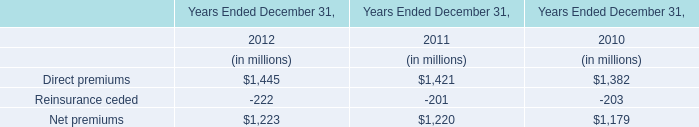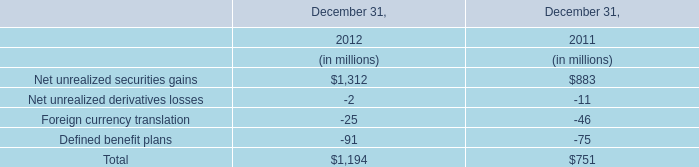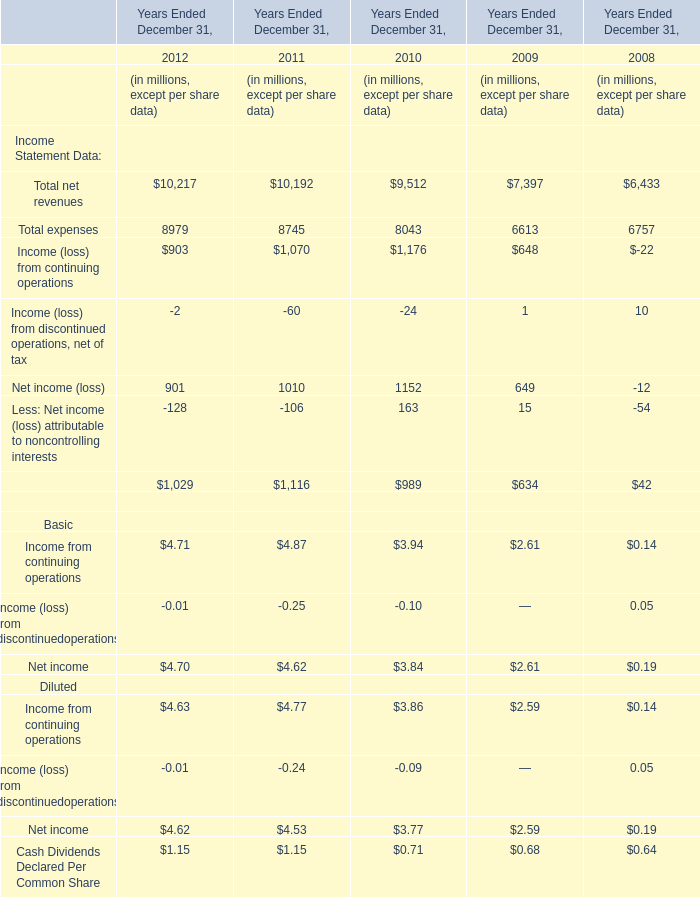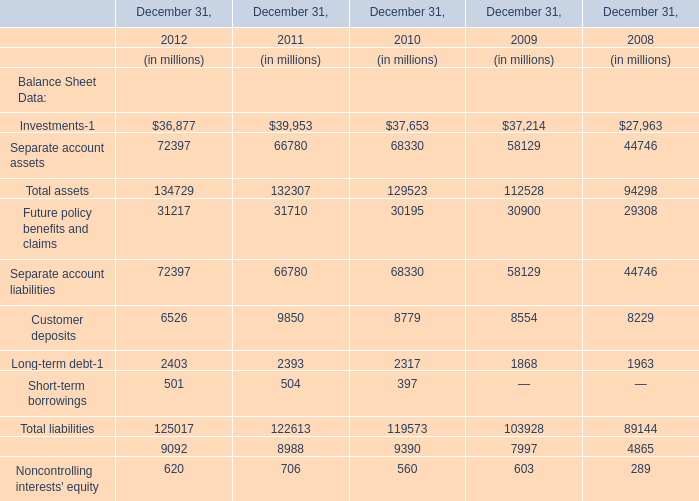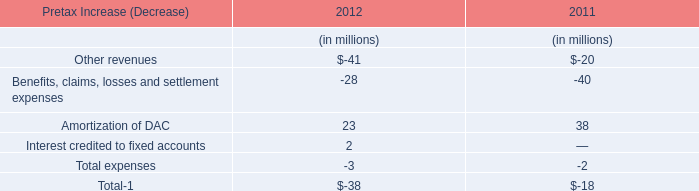What's the average of Investments-1 and Separate account assets and Total assets in 2012? (in million) 
Computations: (((36877 + 72397) + 134729) / 3)
Answer: 81334.33333. 